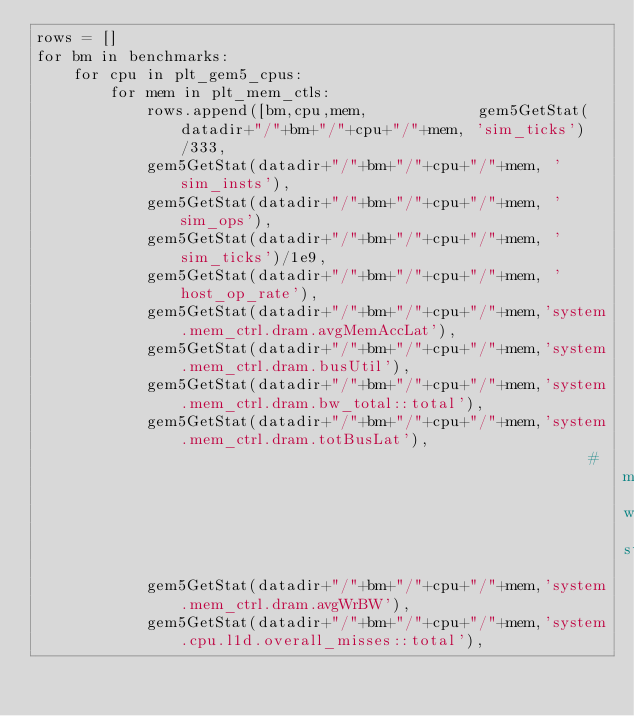Convert code to text. <code><loc_0><loc_0><loc_500><loc_500><_Python_>rows = []
for bm in benchmarks: 
    for cpu in plt_gem5_cpus:
        for mem in plt_mem_ctls:
            rows.append([bm,cpu,mem,            gem5GetStat(datadir+"/"+bm+"/"+cpu+"/"+mem, 'sim_ticks')/333,
            gem5GetStat(datadir+"/"+bm+"/"+cpu+"/"+mem, 'sim_insts'),
            gem5GetStat(datadir+"/"+bm+"/"+cpu+"/"+mem, 'sim_ops'),
            gem5GetStat(datadir+"/"+bm+"/"+cpu+"/"+mem, 'sim_ticks')/1e9,
            gem5GetStat(datadir+"/"+bm+"/"+cpu+"/"+mem, 'host_op_rate'),
            gem5GetStat(datadir+"/"+bm+"/"+cpu+"/"+mem,'system.mem_ctrl.dram.avgMemAccLat'),
            gem5GetStat(datadir+"/"+bm+"/"+cpu+"/"+mem,'system.mem_ctrl.dram.busUtil'),
            gem5GetStat(datadir+"/"+bm+"/"+cpu+"/"+mem,'system.mem_ctrl.dram.bw_total::total'),
            gem5GetStat(datadir+"/"+bm+"/"+cpu+"/"+mem,'system.mem_ctrl.dram.totBusLat'),
                                                            #memory with store
            gem5GetStat(datadir+"/"+bm+"/"+cpu+"/"+mem,'system.mem_ctrl.dram.avgWrBW'),
            gem5GetStat(datadir+"/"+bm+"/"+cpu+"/"+mem,'system.cpu.l1d.overall_misses::total'),</code> 